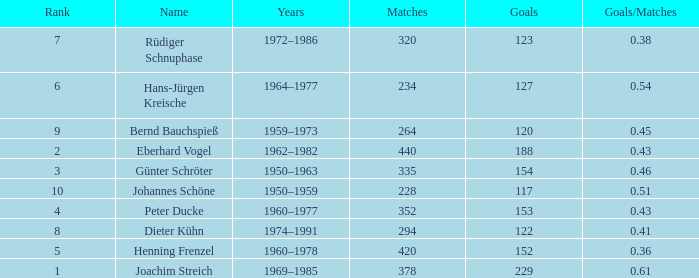What are the lowest goal that have goals/matches greater than 0.43 with joachim streich as the name and matches greater than 378? None. 